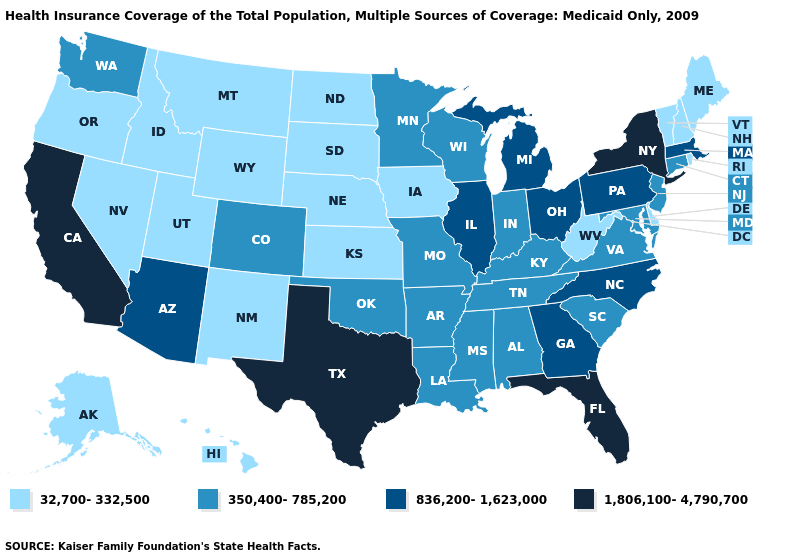What is the lowest value in the Northeast?
Be succinct. 32,700-332,500. What is the value of New Mexico?
Answer briefly. 32,700-332,500. Does New Hampshire have a lower value than Washington?
Concise answer only. Yes. What is the value of Pennsylvania?
Give a very brief answer. 836,200-1,623,000. What is the value of North Dakota?
Quick response, please. 32,700-332,500. Among the states that border Pennsylvania , does Maryland have the lowest value?
Concise answer only. No. Does California have the highest value in the USA?
Keep it brief. Yes. Is the legend a continuous bar?
Give a very brief answer. No. Name the states that have a value in the range 32,700-332,500?
Write a very short answer. Alaska, Delaware, Hawaii, Idaho, Iowa, Kansas, Maine, Montana, Nebraska, Nevada, New Hampshire, New Mexico, North Dakota, Oregon, Rhode Island, South Dakota, Utah, Vermont, West Virginia, Wyoming. How many symbols are there in the legend?
Give a very brief answer. 4. What is the value of Hawaii?
Short answer required. 32,700-332,500. Which states have the lowest value in the USA?
Be succinct. Alaska, Delaware, Hawaii, Idaho, Iowa, Kansas, Maine, Montana, Nebraska, Nevada, New Hampshire, New Mexico, North Dakota, Oregon, Rhode Island, South Dakota, Utah, Vermont, West Virginia, Wyoming. Among the states that border Michigan , does Ohio have the highest value?
Short answer required. Yes. Does California have the highest value in the USA?
Short answer required. Yes. 